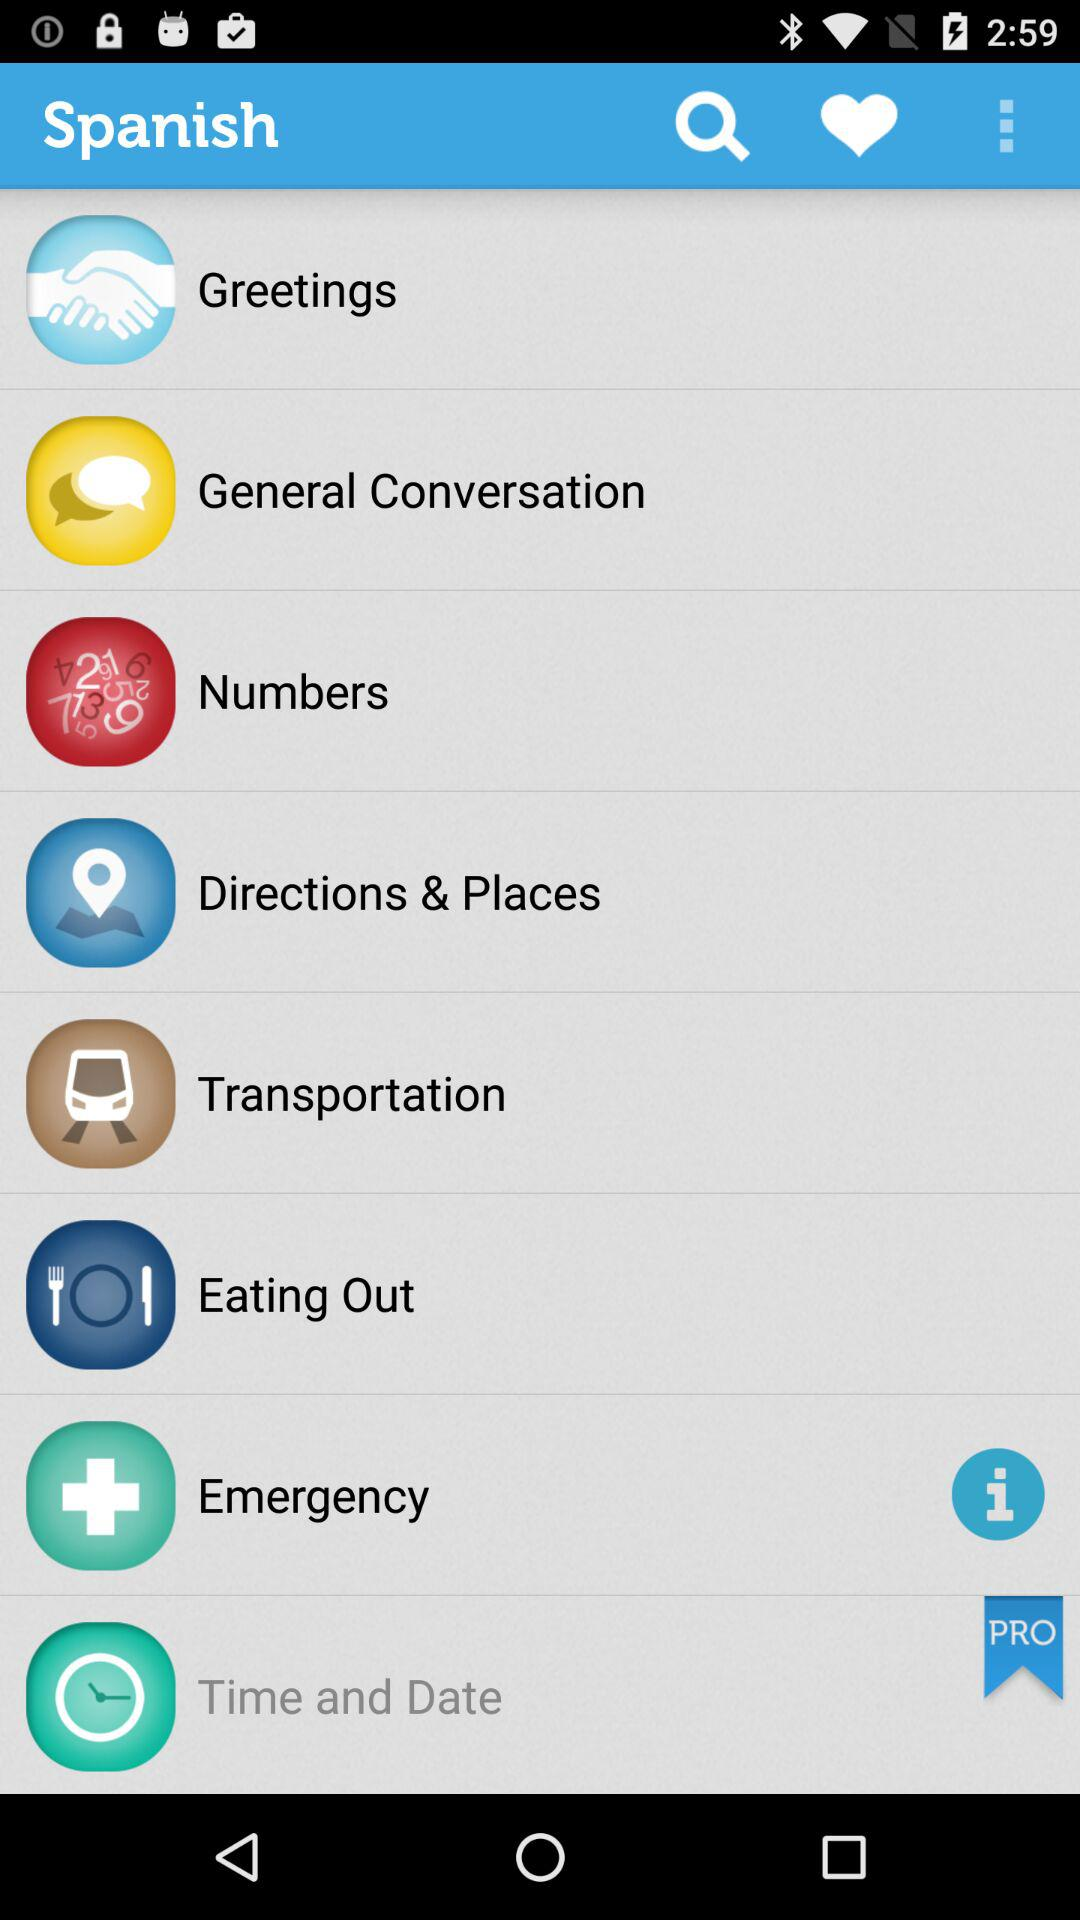Which option is available in the pro version? The available option is "Time and Date". 